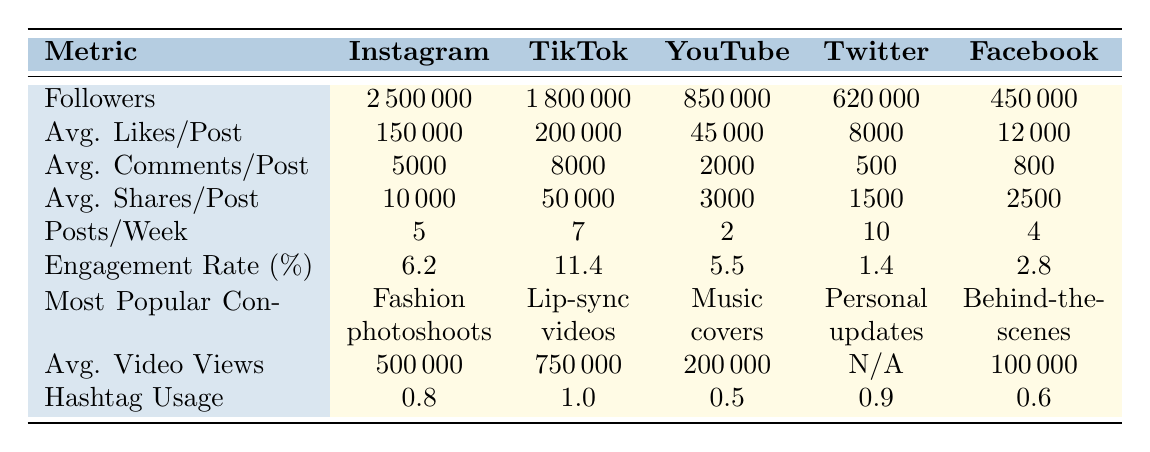What platform has the highest number of followers? From the table, Instagram has 2,500,000 followers, which is more than any other platform listed. TikTok follows with 1,800,000, which is significantly less than Instagram.
Answer: Instagram Which platform has the highest engagement rate? The engagement rates for the platforms are listed, with TikTok having the highest at 11.4%, while Twitter has the lowest at 1.4%.
Answer: TikTok How many more likes per post does TikTok have compared to Facebook? TikTok has an average of 200,000 likes per post, while Facebook has 12,000. The difference is calculated as 200,000 - 12,000 = 188,000.
Answer: 188000 What is the total number of posts per week across all platforms? To find the total posts per week, we sum the posts from all platforms: 5 (Instagram) + 7 (TikTok) + 2 (YouTube) + 10 (Twitter) + 4 (Facebook) = 28 posts.
Answer: 28 Is the average number of comments per post on YouTube higher than on Facebook? YouTube has 2,000 comments per post while Facebook has 800. Since 2,000 is greater than 800, the statement is true.
Answer: Yes What is the average number of average likes per post across all platforms? First, we sum the average likes from all platforms: 150,000 + 200,000 + 45,000 + 8,000 + 12,000 = 415,000. Then, we divide by the number of platforms (5) to find the average: 415,000 / 5 = 83,000.
Answer: 83000 Which platform has the lowest average shares per post? From the data, Twitter has the lowest average shares per post at 1,500, compared to other platforms like Instagram and TikTok.
Answer: Twitter What percentage of posts on Instagram include hashtags? The table indicates that Instagram has a hashtag usage frequency of 0.8. If we convert this to a percentage, it means that 80% of posts use hashtags.
Answer: 80% If Sofia posts an average of 5 times a week on Instagram, how many likes will she get in a month? With an average of 150,000 likes per post and posting 5 times a week, the total likes from Instagram can be calculated as follows: 150,000 likes/post * 5 posts/week * 4 weeks = 3,000,000 likes/month.
Answer: 3000000 How does Sofia's average video views on TikTok compare to YouTube? TikTok's average video views are 750,000 while YouTube has 200,000. Comparing these values (750,000 > 200,000), TikTok has more views.
Answer: TikTok has more views 